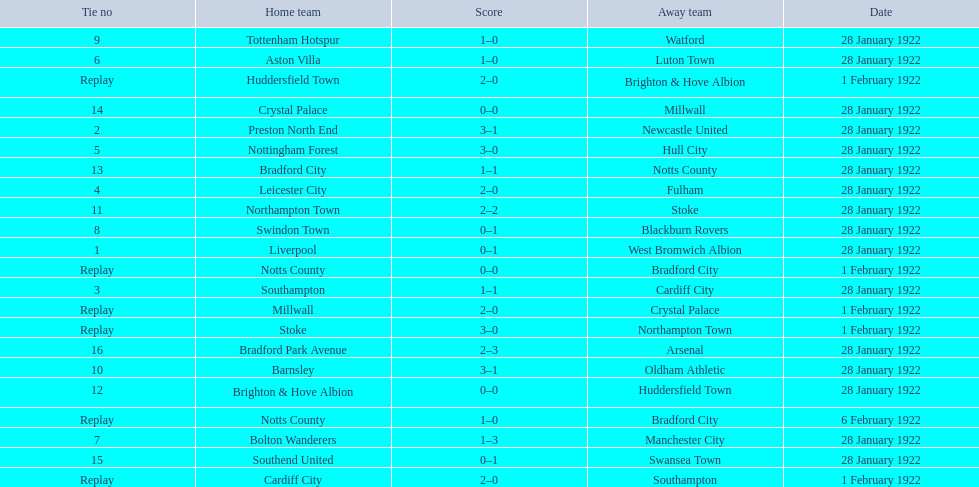Which team had a score of 0-1? Liverpool. Which team had a replay? Cardiff City. Could you help me parse every detail presented in this table? {'header': ['Tie no', 'Home team', 'Score', 'Away team', 'Date'], 'rows': [['9', 'Tottenham Hotspur', '1–0', 'Watford', '28 January 1922'], ['6', 'Aston Villa', '1–0', 'Luton Town', '28 January 1922'], ['Replay', 'Huddersfield Town', '2–0', 'Brighton & Hove Albion', '1 February 1922'], ['14', 'Crystal Palace', '0–0', 'Millwall', '28 January 1922'], ['2', 'Preston North End', '3–1', 'Newcastle United', '28 January 1922'], ['5', 'Nottingham Forest', '3–0', 'Hull City', '28 January 1922'], ['13', 'Bradford City', '1–1', 'Notts County', '28 January 1922'], ['4', 'Leicester City', '2–0', 'Fulham', '28 January 1922'], ['11', 'Northampton Town', '2–2', 'Stoke', '28 January 1922'], ['8', 'Swindon Town', '0–1', 'Blackburn Rovers', '28 January 1922'], ['1', 'Liverpool', '0–1', 'West Bromwich Albion', '28 January 1922'], ['Replay', 'Notts County', '0–0', 'Bradford City', '1 February 1922'], ['3', 'Southampton', '1–1', 'Cardiff City', '28 January 1922'], ['Replay', 'Millwall', '2–0', 'Crystal Palace', '1 February 1922'], ['Replay', 'Stoke', '3–0', 'Northampton Town', '1 February 1922'], ['16', 'Bradford Park Avenue', '2–3', 'Arsenal', '28 January 1922'], ['10', 'Barnsley', '3–1', 'Oldham Athletic', '28 January 1922'], ['12', 'Brighton & Hove Albion', '0–0', 'Huddersfield Town', '28 January 1922'], ['Replay', 'Notts County', '1–0', 'Bradford City', '6 February 1922'], ['7', 'Bolton Wanderers', '1–3', 'Manchester City', '28 January 1922'], ['15', 'Southend United', '0–1', 'Swansea Town', '28 January 1922'], ['Replay', 'Cardiff City', '2–0', 'Southampton', '1 February 1922']]} Which team had the same score as aston villa? Tottenham Hotspur. 